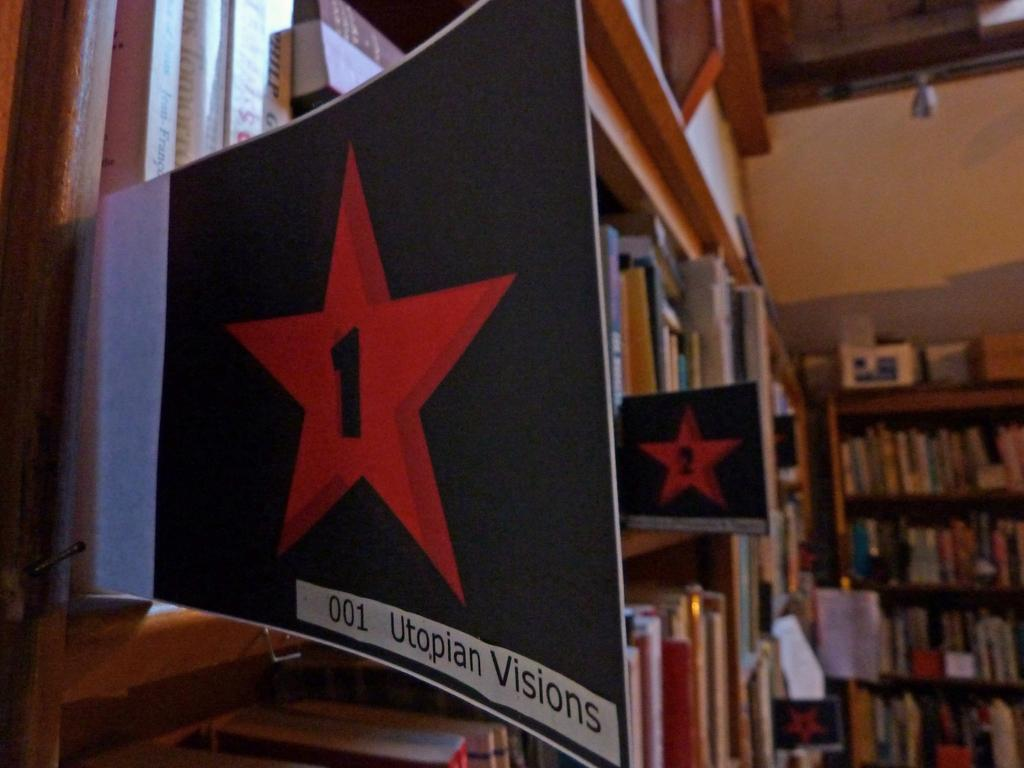<image>
Present a compact description of the photo's key features. A packed group of shelves with signs that say Utopian Visions. 